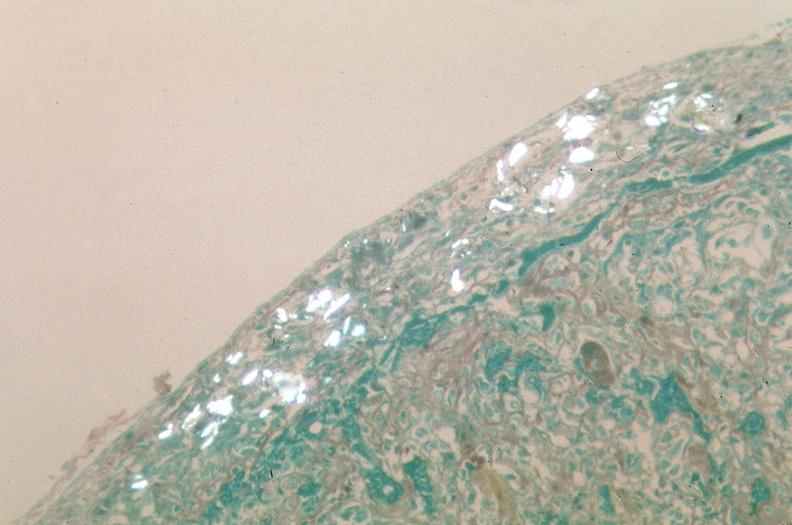does trichrome stain?
Answer the question using a single word or phrase. Yes 